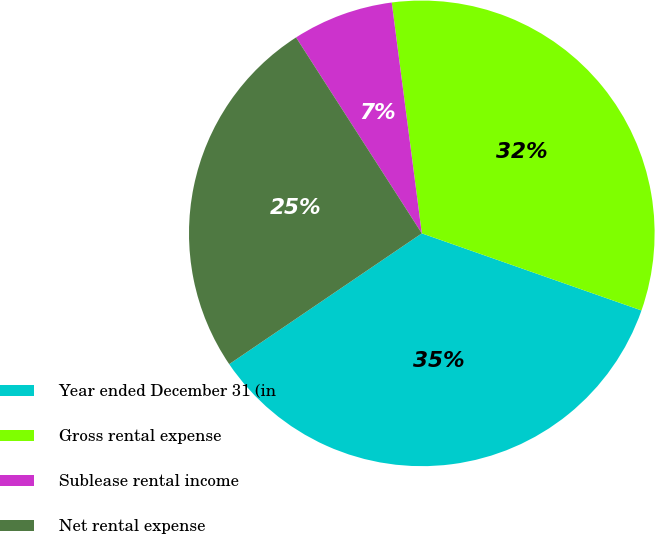Convert chart. <chart><loc_0><loc_0><loc_500><loc_500><pie_chart><fcel>Year ended December 31 (in<fcel>Gross rental expense<fcel>Sublease rental income<fcel>Net rental expense<nl><fcel>35.13%<fcel>32.43%<fcel>7.02%<fcel>25.41%<nl></chart> 